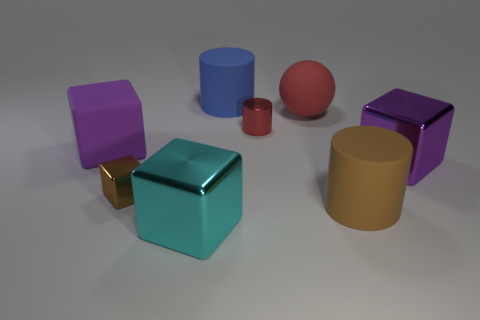Subtract all red blocks. Subtract all yellow spheres. How many blocks are left? 4 Add 1 objects. How many objects exist? 9 Subtract all cylinders. How many objects are left? 5 Add 7 small gray balls. How many small gray balls exist? 7 Subtract 1 red cylinders. How many objects are left? 7 Subtract all tiny cyan rubber blocks. Subtract all big matte objects. How many objects are left? 4 Add 3 small blocks. How many small blocks are left? 4 